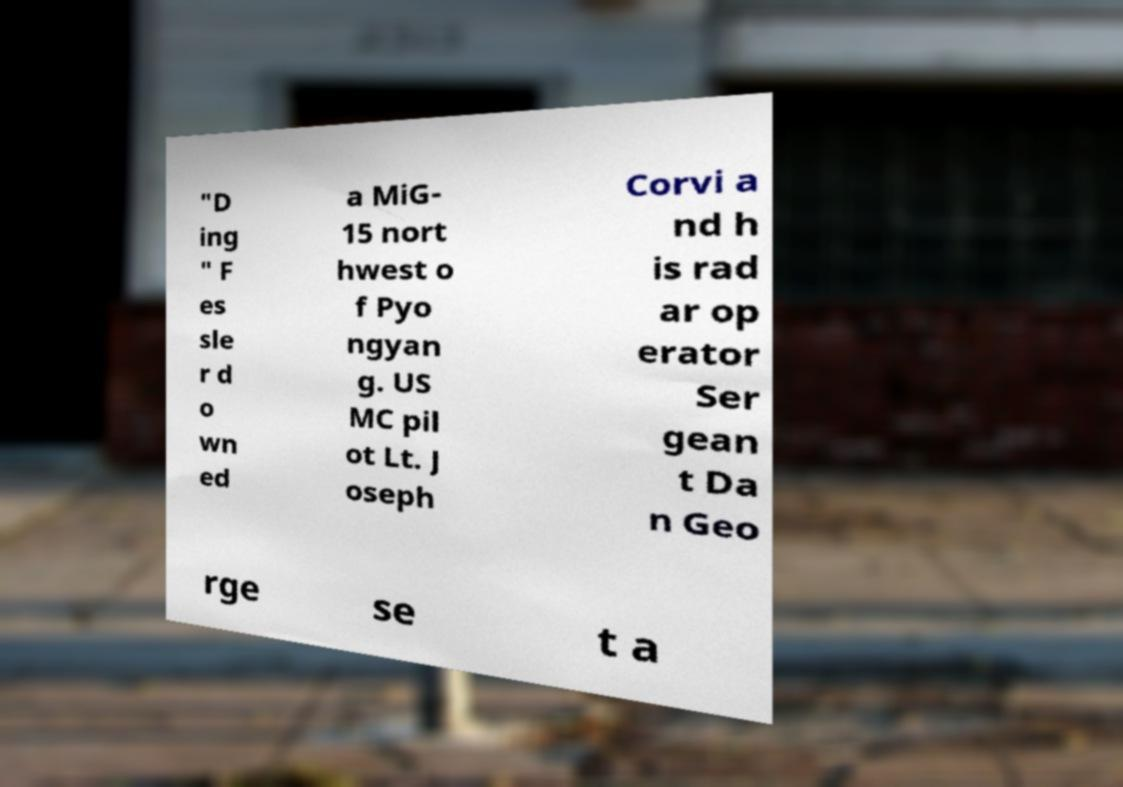I need the written content from this picture converted into text. Can you do that? "D ing " F es sle r d o wn ed a MiG- 15 nort hwest o f Pyo ngyan g. US MC pil ot Lt. J oseph Corvi a nd h is rad ar op erator Ser gean t Da n Geo rge se t a 